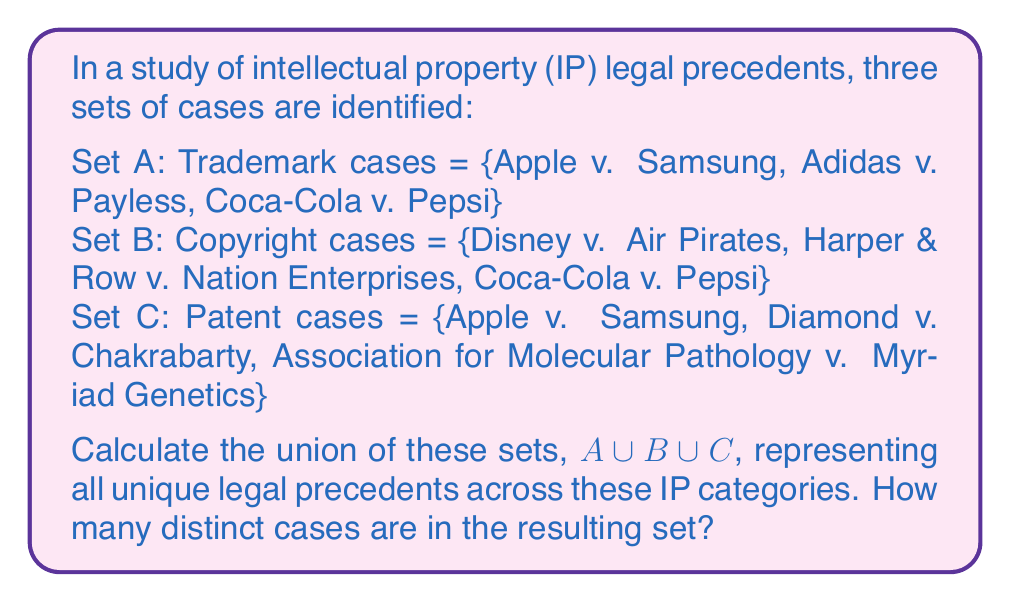Help me with this question. To solve this problem, we need to follow these steps:

1. Identify all unique elements across the three sets.
2. Count the number of these unique elements.

Let's break it down:

1. Set A (Trademark cases): 
   - Apple v. Samsung
   - Adidas v. Payless
   - Coca-Cola v. Pepsi

2. Set B (Copyright cases):
   - Disney v. Air Pirates
   - Harper & Row v. Nation Enterprises
   - Coca-Cola v. Pepsi

3. Set C (Patent cases):
   - Apple v. Samsung
   - Diamond v. Chakrabarty
   - Association for Molecular Pathology v. Myriad Genetics

Now, let's identify the unique cases across all sets:

1. Apple v. Samsung (appears in A and C)
2. Adidas v. Payless
3. Coca-Cola v. Pepsi (appears in A and B)
4. Disney v. Air Pirates
5. Harper & Row v. Nation Enterprises
6. Diamond v. Chakrabarty
7. Association for Molecular Pathology v. Myriad Genetics

The union of sets A, B, and C is represented mathematically as:

$A \cup B \cup C = \{x : x \in A \text{ or } x \in B \text{ or } x \in C\}$

This union contains all elements that appear in at least one of the sets, without duplicates.

Counting the unique elements in our list, we get 7 distinct cases.
Answer: The union of sets A, B, and C contains 7 distinct legal precedents. 